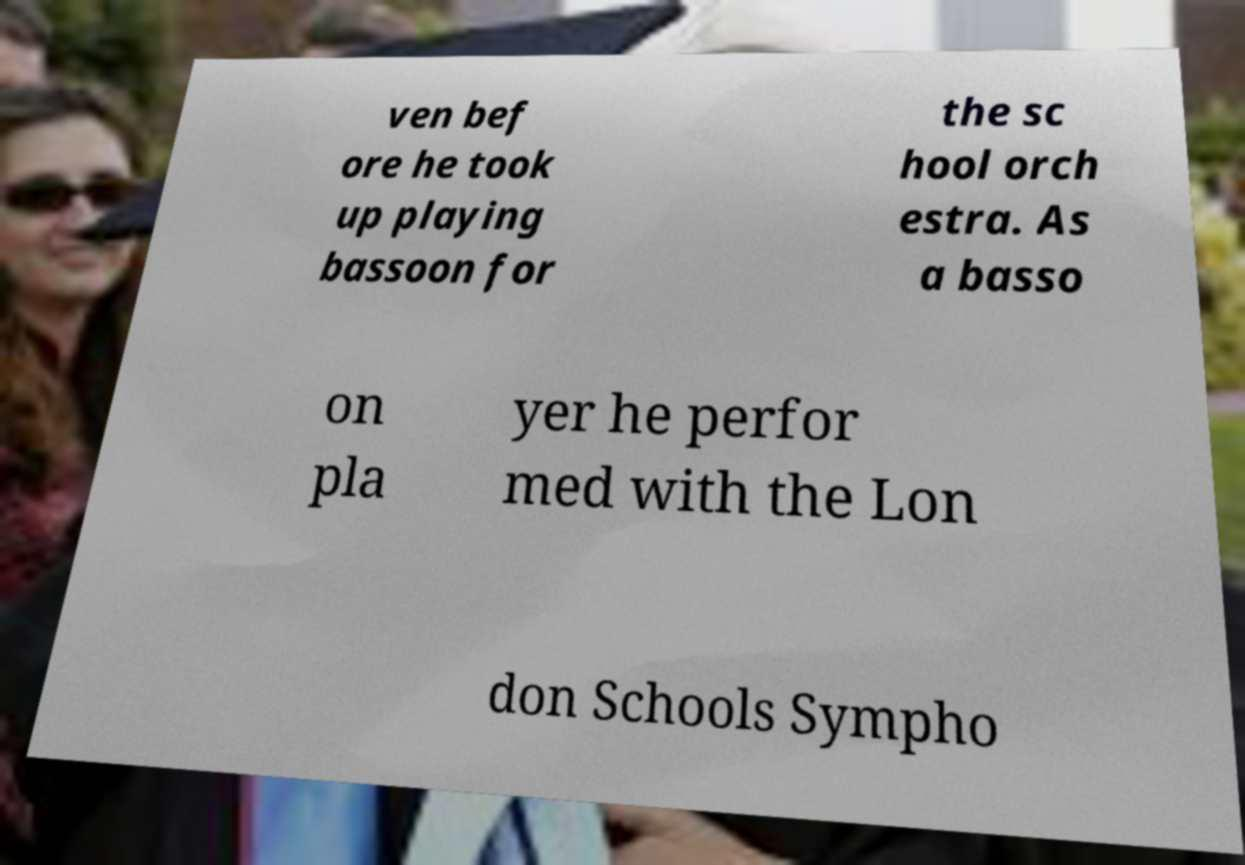Please read and relay the text visible in this image. What does it say? ven bef ore he took up playing bassoon for the sc hool orch estra. As a basso on pla yer he perfor med with the Lon don Schools Sympho 